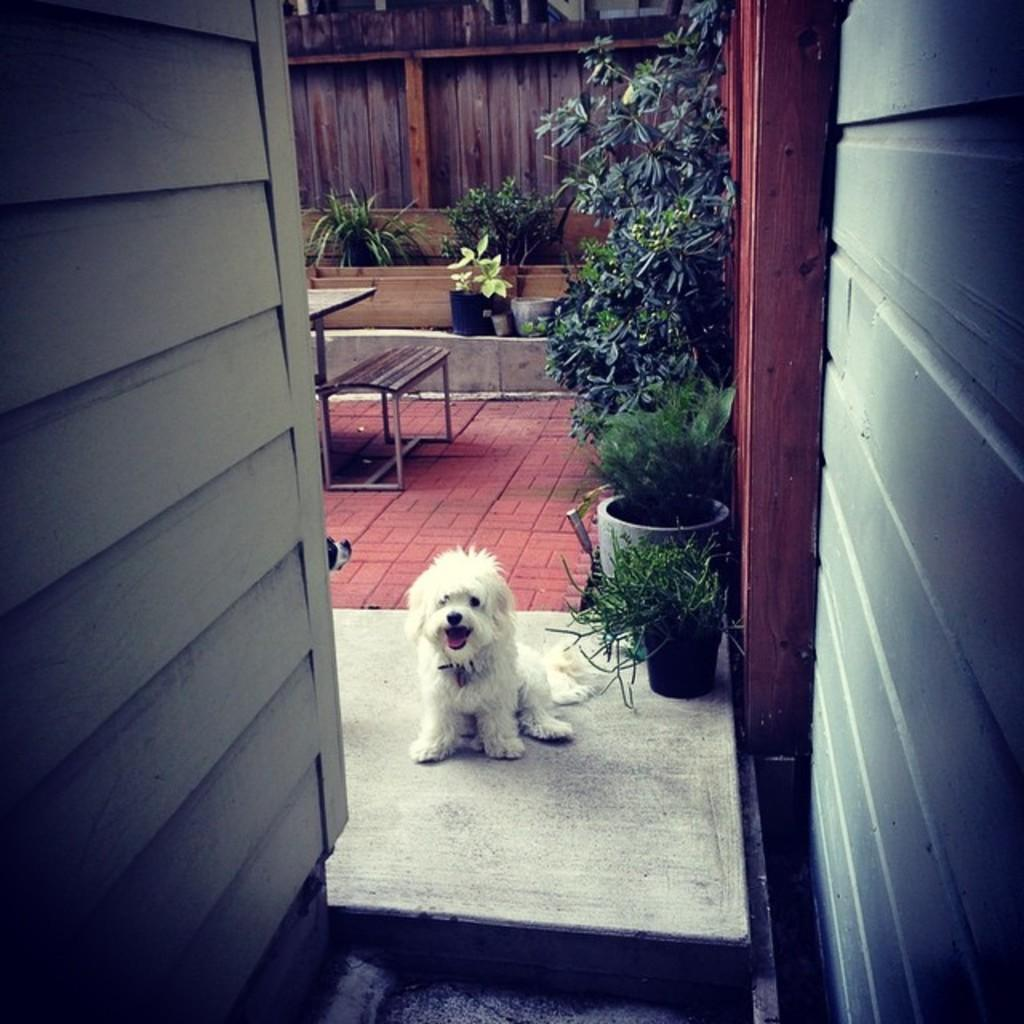What animal is on the floor in the image? There is a dog on the floor in the image. What can be seen in the background of the image? There are flower pots, a table, and windows in the background of the image. How many boys are sitting on the dog in the image? There are no boys present in the image, and the dog is not being sat on. 